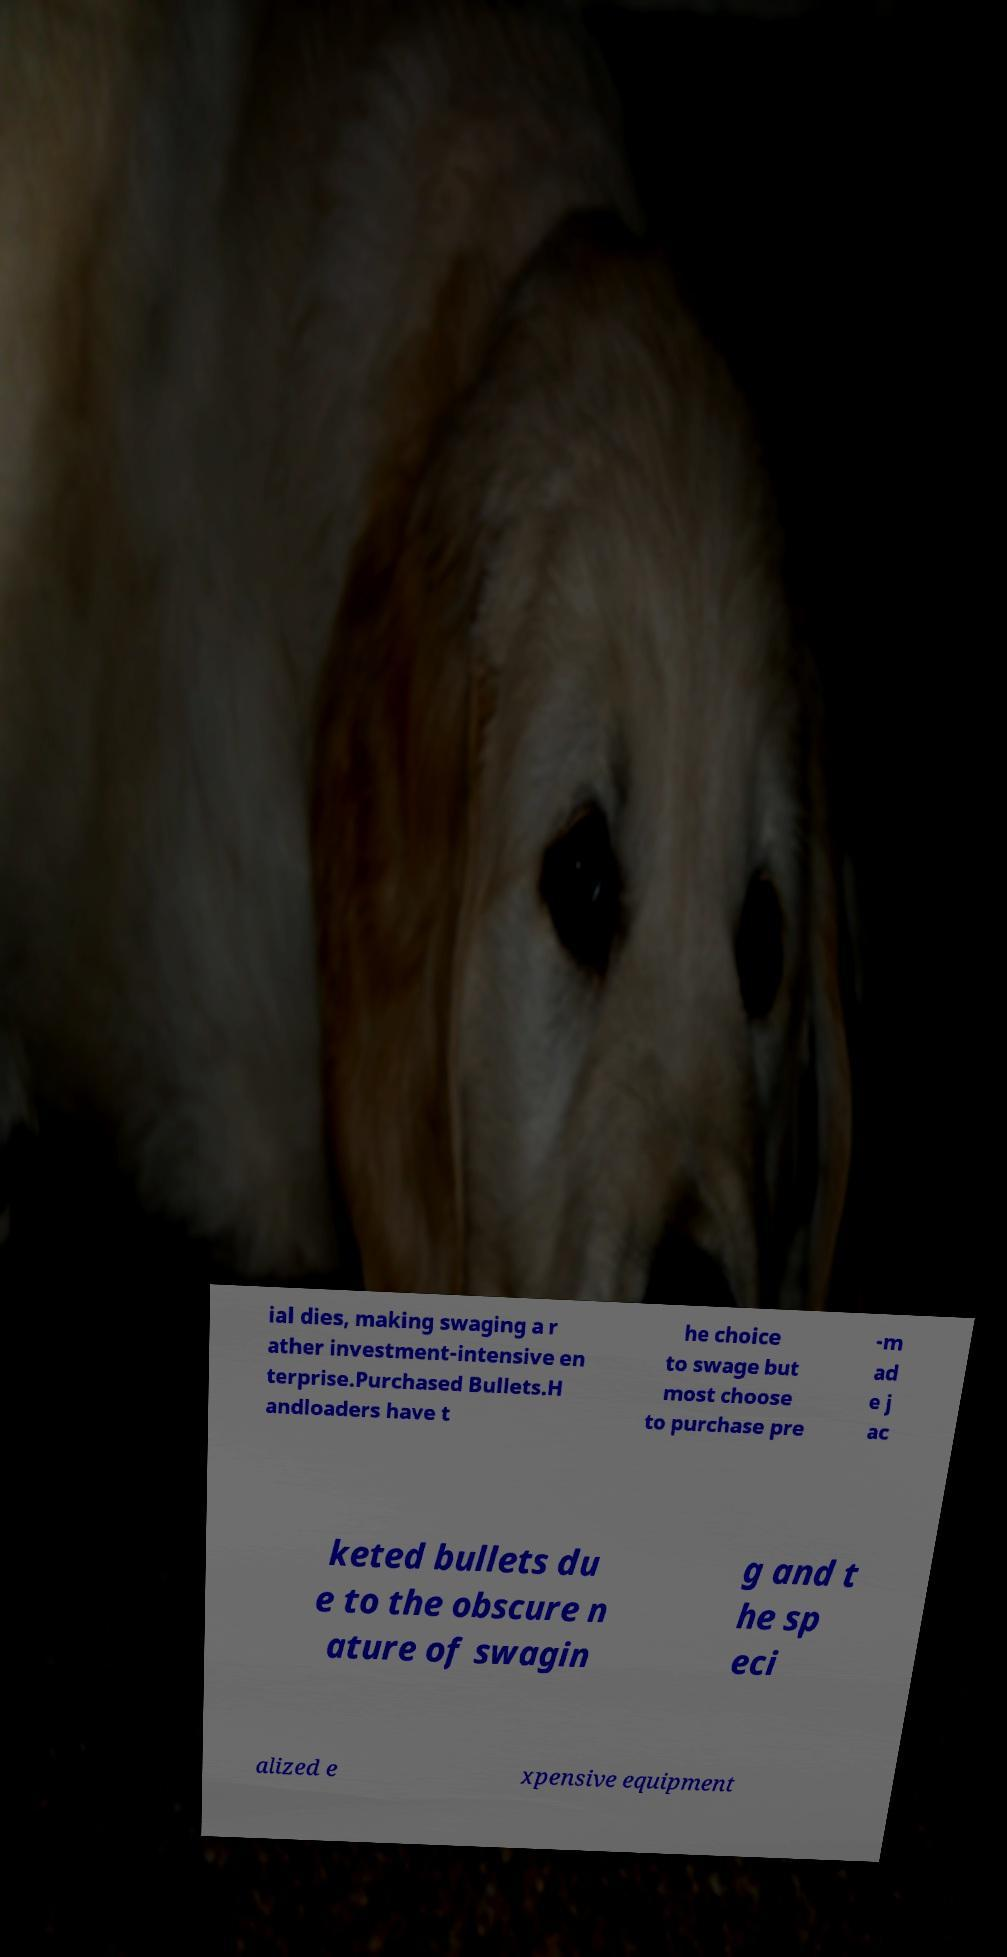Can you read and provide the text displayed in the image?This photo seems to have some interesting text. Can you extract and type it out for me? ial dies, making swaging a r ather investment-intensive en terprise.Purchased Bullets.H andloaders have t he choice to swage but most choose to purchase pre -m ad e j ac keted bullets du e to the obscure n ature of swagin g and t he sp eci alized e xpensive equipment 